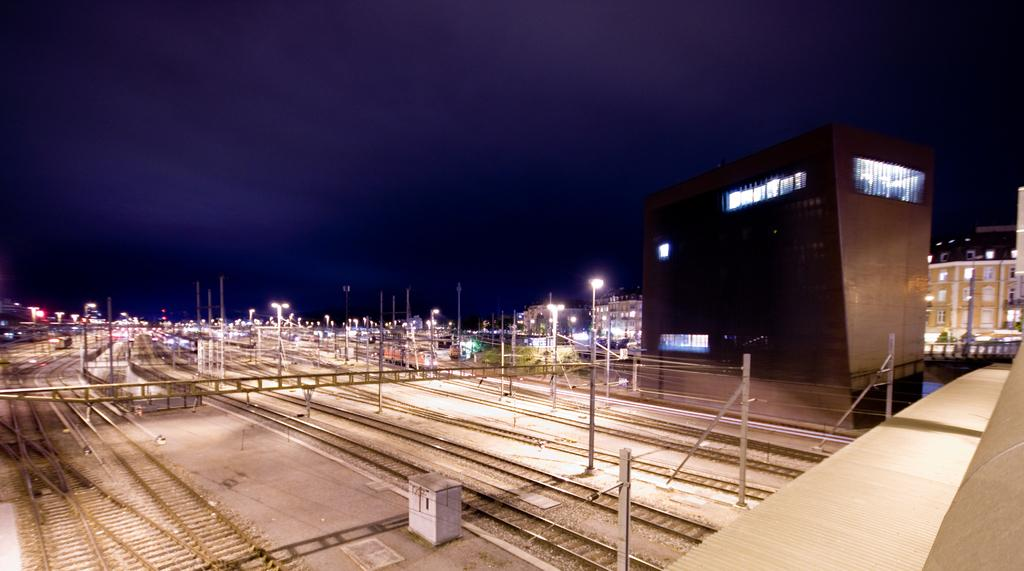What type of transportation infrastructure is visible in the image? There are railway tracks in the image. What other structures can be seen in the image? There are electricity poles, buildings, and street lights in the image. What is visible in the sky in the image? The sky is visible in the image, and clouds are present. Where are the boats docked in the image? There are no boats present in the image. What type of meeting is taking place in the image? There is no meeting depicted in the image. 